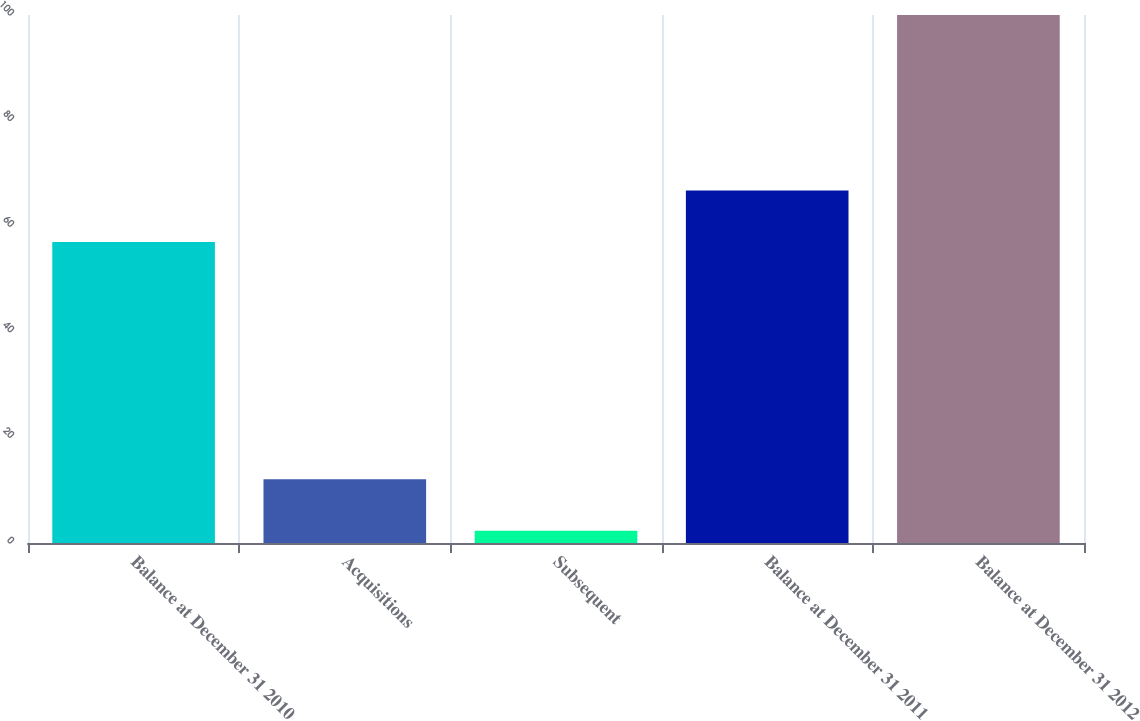Convert chart to OTSL. <chart><loc_0><loc_0><loc_500><loc_500><bar_chart><fcel>Balance at December 31 2010<fcel>Acquisitions<fcel>Subsequent<fcel>Balance at December 31 2011<fcel>Balance at December 31 2012<nl><fcel>57<fcel>12.09<fcel>2.32<fcel>66.77<fcel>100<nl></chart> 